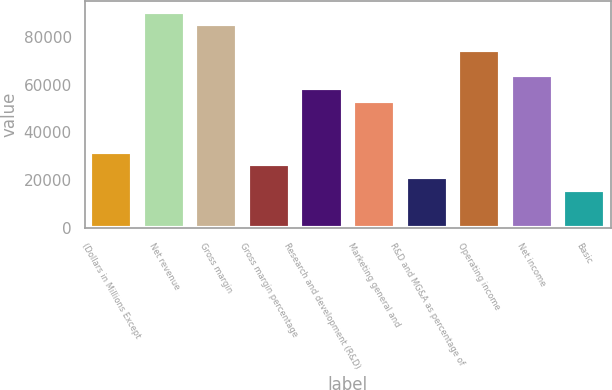Convert chart. <chart><loc_0><loc_0><loc_500><loc_500><bar_chart><fcel>(Dollars in Millions Except<fcel>Net revenue<fcel>Gross margin<fcel>Gross margin percentage<fcel>Research and development (R&D)<fcel>Marketing general and<fcel>R&D and MG&A as percentage of<fcel>Operating income<fcel>Net income<fcel>Basic<nl><fcel>32004.9<fcel>90679<fcel>85345<fcel>26670.9<fcel>58675<fcel>53341<fcel>21336.9<fcel>74677<fcel>64009<fcel>16002.9<nl></chart> 